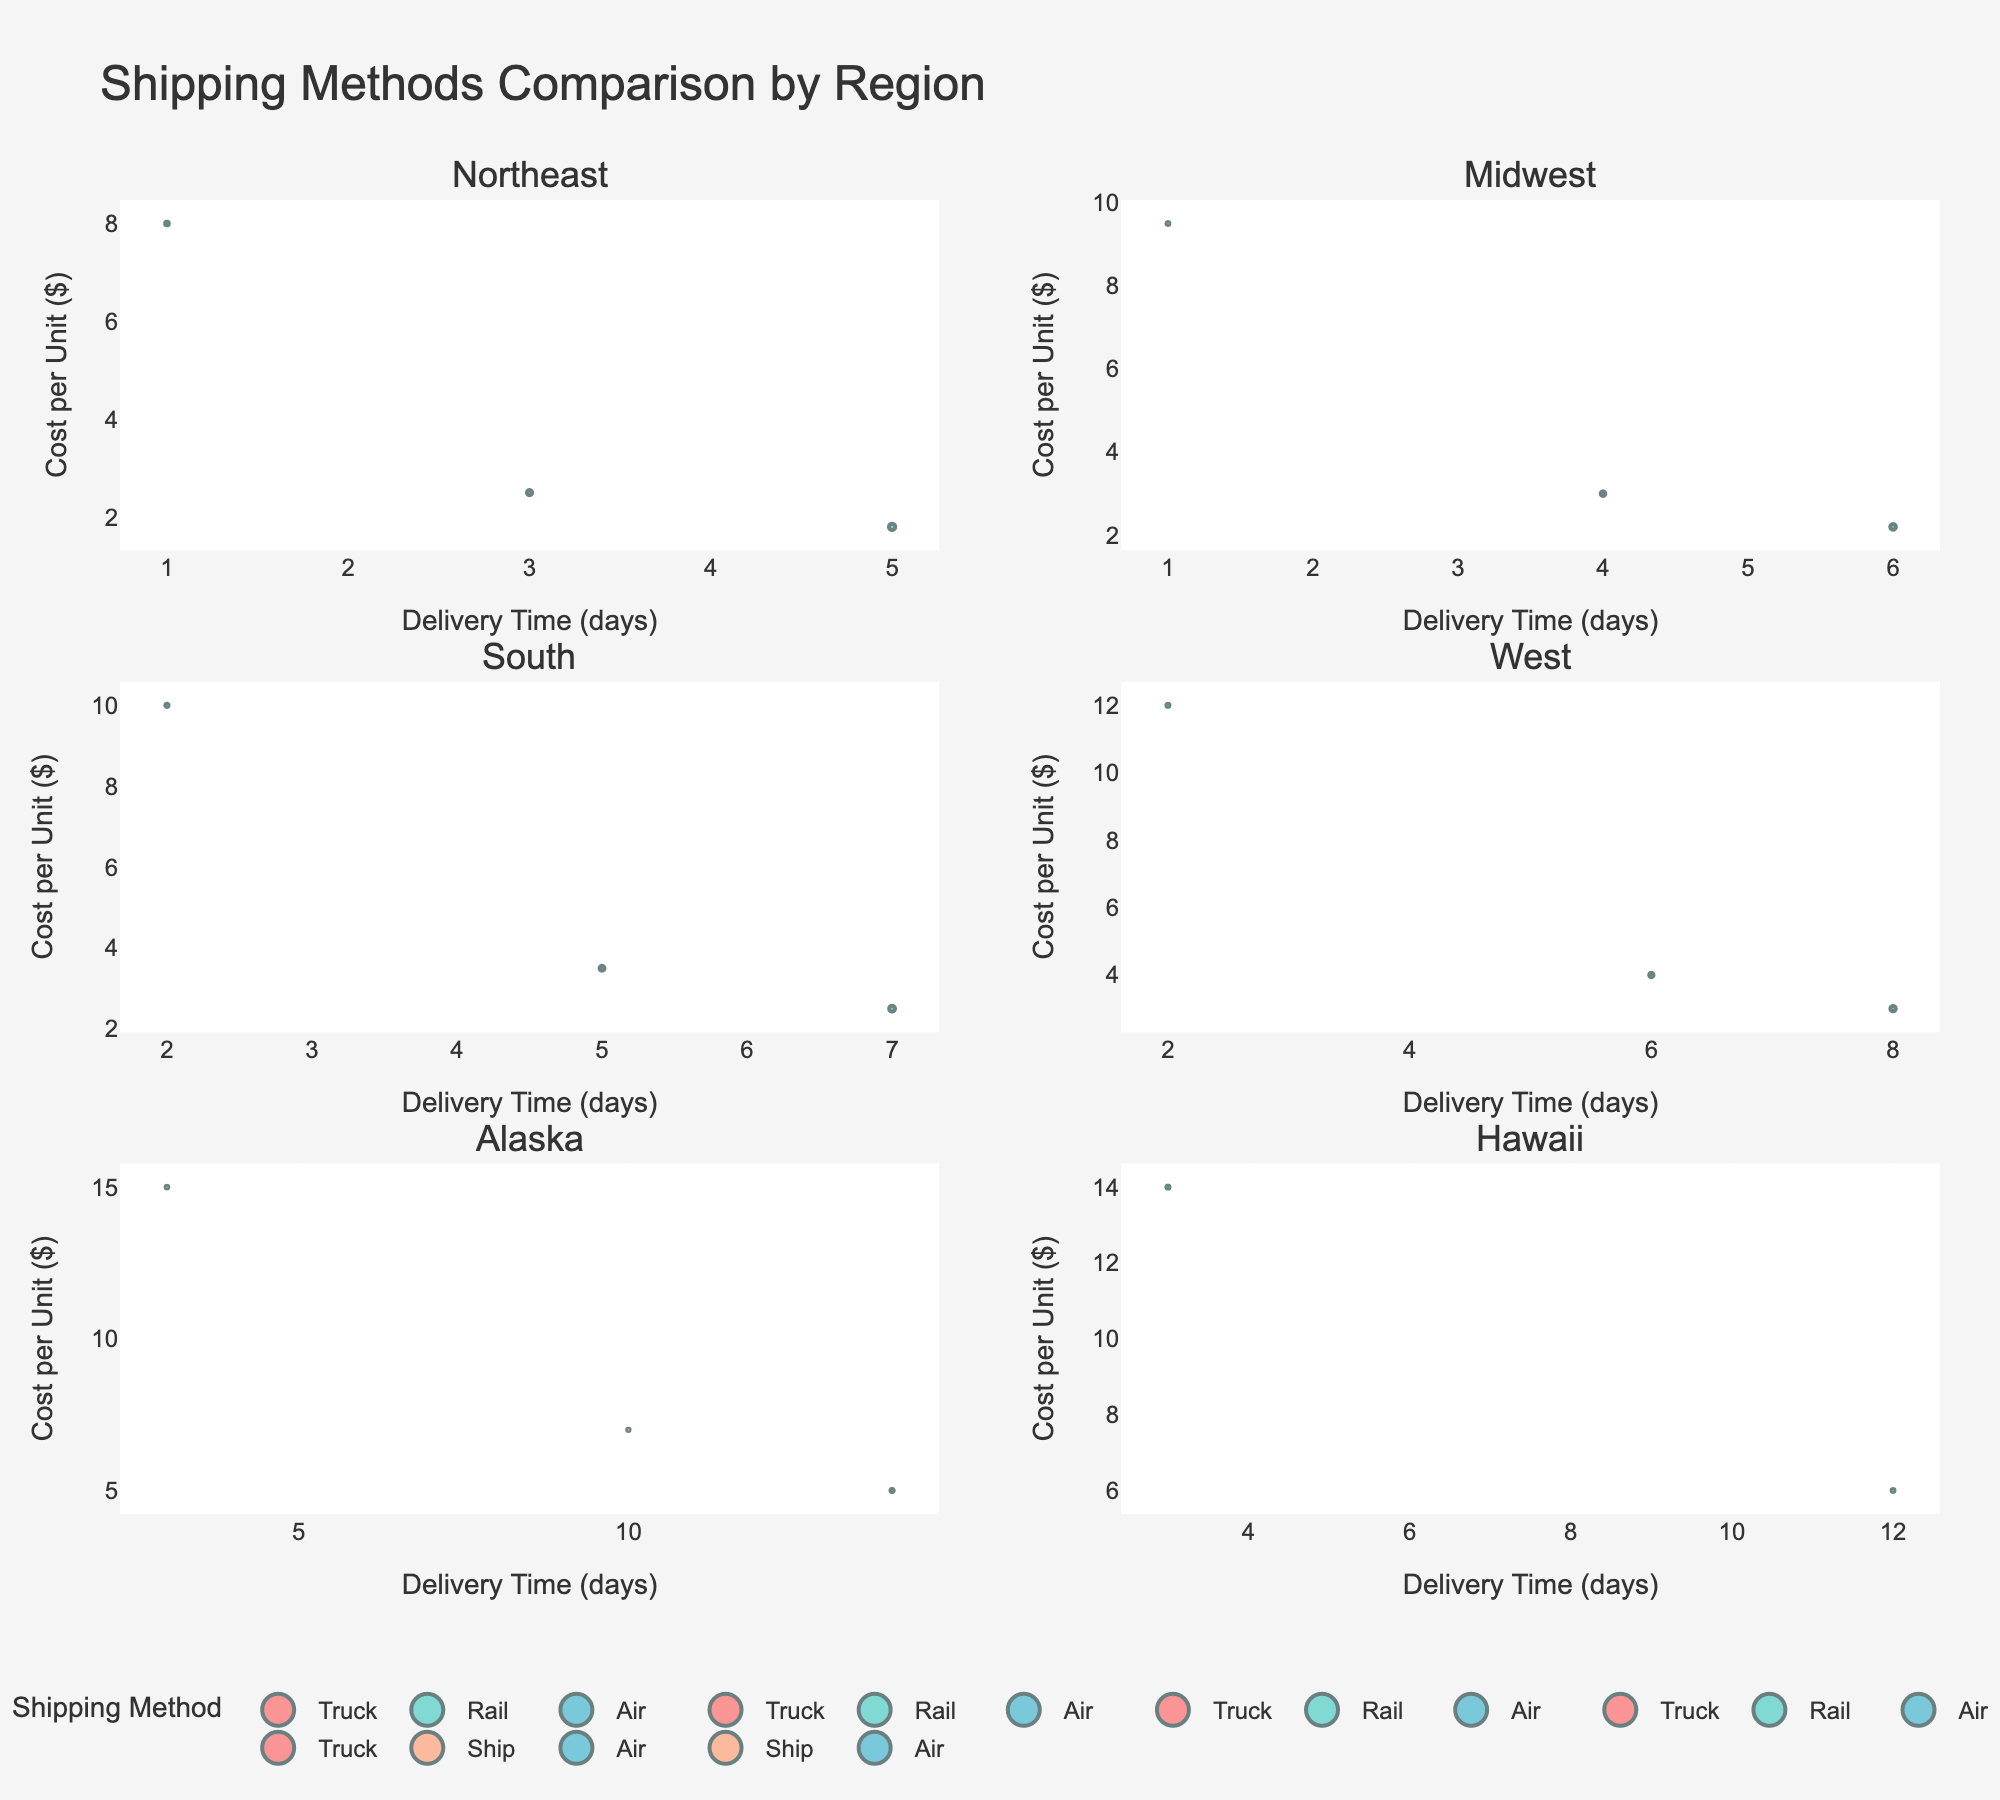What is the title of the figure? The title is displayed at the top center of the figure. It reads "Shell Script Complexity Across Linux Distributions".
Answer: Shell Script Complexity Across Linux Distributions Which distribution has the highest complexity score? In the "Complexity vs. User Base" subplot, the distribution with the highest y-coordinate represents the highest complexity. Arch Linux's point is at the top.
Answer: Arch Linux What's the relationship between the size of bubbles and line counts in the "Line Count vs. User Base" subplot? The size of the bubbles is proportional to the complexity score, with larger bubbles indicating higher complexity. The different colors indicate varying line counts.
Answer: Bubble size is proportional to complexity Which distribution has the smallest average line count? In the "Line Count vs. User Base" subplot, the distribution with the lowest y-coordinate represents the smallest average line count. Elementary OS's point is at the bottom.
Answer: Elementary OS Compare the complexity and user base of Fedora and CentOS. Which has a higher complexity score? In the "Complexity vs. User Base" subplot, compare the y-coordinates of Fedora and CentOS. Fedora's y-coordinate is higher than CentOS's, indicating a higher complexity score.
Answer: Fedora What distribution has the largest number of users? In both subplots, the distribution with the highest x-coordinate has the largest user base. Ubuntu's point is farthest to the right.
Answer: Ubuntu How does the user base of Arch Linux compare to Debian? In any of the subplots, compare the x-coordinates. Arch Linux is situated left of Debian, indicating a smaller user base.
Answer: Arch Linux has a smaller user base What's the average complexity score and average line count for Ubuntu and Fedora distributions? For "Complexity vs. User Base", add complexity scores of both distributions, divide by 2. For "Line Count vs. User Base", add line counts of both, divide by 2. Ubuntu: Complexity 7.2, Line Count 85. Fedora: Complexity 8.1, Line Count 110. Avg Complexity = (7.2 + 8.1) / 2 = 7.65. Avg Line Count = (85 + 110) / 2 = 97.5.
Answer: Avg Complexity: 7.65; Avg Line Count: 97.5 Which distribution has the highest average line count, and how does its user base compare to that of Kali Linux? In the "Line Count vs. User Base" subplot, Arch Linux shows the highest line count (farthest up on y-axis). Comparing their x-coordinates in the same subplot, Arch Linux has a higher user base than Kali Linux.
Answer: Arch Linux; Arch Linux has a higher user base 